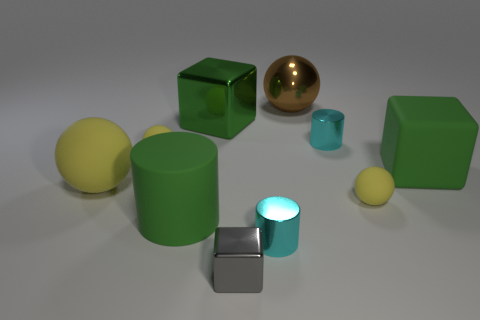How many yellow matte objects are on the left side of the large cylinder and in front of the rubber block?
Your response must be concise. 1. The matte thing that is to the left of the yellow object that is behind the green rubber cube is what color?
Ensure brevity in your answer.  Yellow. What number of rubber balls are the same color as the big shiny ball?
Offer a terse response. 0. Is the color of the big rubber block the same as the small thing that is on the left side of the big green matte cylinder?
Provide a succinct answer. No. Is the number of shiny things less than the number of small cyan shiny cylinders?
Make the answer very short. No. Are there more cylinders right of the big green rubber cylinder than big blocks left of the small gray shiny cube?
Make the answer very short. Yes. Does the brown ball have the same material as the green cylinder?
Your answer should be very brief. No. There is a green matte thing that is to the right of the green matte cylinder; how many green matte objects are left of it?
Provide a succinct answer. 1. Is the color of the shiny cylinder that is on the right side of the big metal sphere the same as the tiny block?
Your response must be concise. No. How many things are cylinders or large spheres in front of the big brown shiny ball?
Your answer should be compact. 4. 